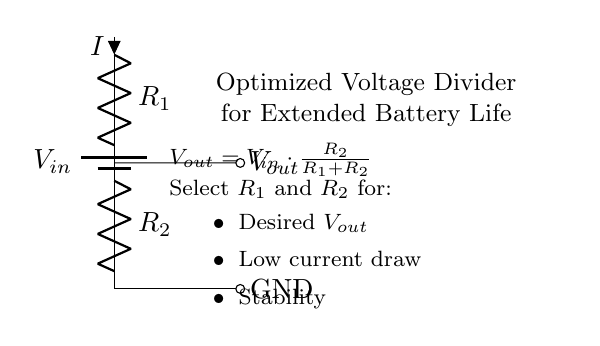What is the input voltage label in the circuit? In the circuit diagram, the input voltage is labeled as \( V_{in} \). This label represents the voltage supplied to the circuit from a battery.
Answer: \( V_{in} \) What are the resistor values represented in this circuit? The circuit does not specify resistor values but labels them as \( R_1 \) and \( R_2 \). These labels indicate that they are adjustable components to achieve the desired output voltage.
Answer: \( R_1, R_2 \) What formula is provided for the output voltage? The output voltage formula given in the circuit is \( V_{out} = V_{in} \cdot \frac{R_2}{R_1 + R_2} \). This equation describes how the output voltage is derived based on the input voltage and the resistor values.
Answer: \( V_{out} = V_{in} \cdot \frac{R_2}{R_1 + R_2} \) Why should \( R_1 \) and \( R_2 \) be selected for low current draw? Low current draw is important in a voltage divider to extend battery life in portable devices. High current draw would lead to faster depletion of battery, increasing replacement costs. The selection of resistor values affects this current draw.
Answer: To extend battery life What is the purpose of this voltage divider circuit? The voltage divider is designed to optimize battery life for portable devices by providing a specific output voltage while minimizing current consumption, thus reducing the frequency of battery replacements.
Answer: Battery life optimization What output should be achieved with the circuit? The desired output voltage, \( V_{out} \), can be adjusted via the selection of \( R_1 \) and \( R_2 \) to meet the specific requirements of the device powered by the circuit, as shown in the label.
Answer: Desired \( V_{out} \) 